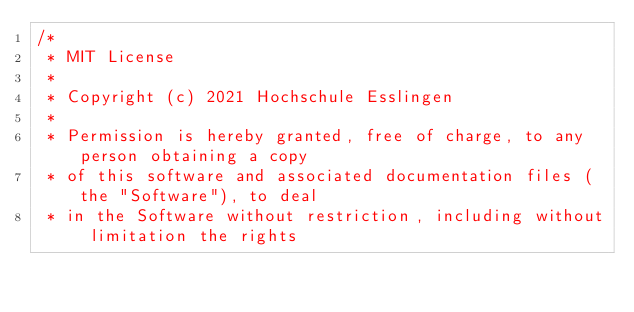Convert code to text. <code><loc_0><loc_0><loc_500><loc_500><_Java_>/*
 * MIT License
 * 
 * Copyright (c) 2021 Hochschule Esslingen
 * 
 * Permission is hereby granted, free of charge, to any person obtaining a copy
 * of this software and associated documentation files (the "Software"), to deal
 * in the Software without restriction, including without limitation the rights</code> 